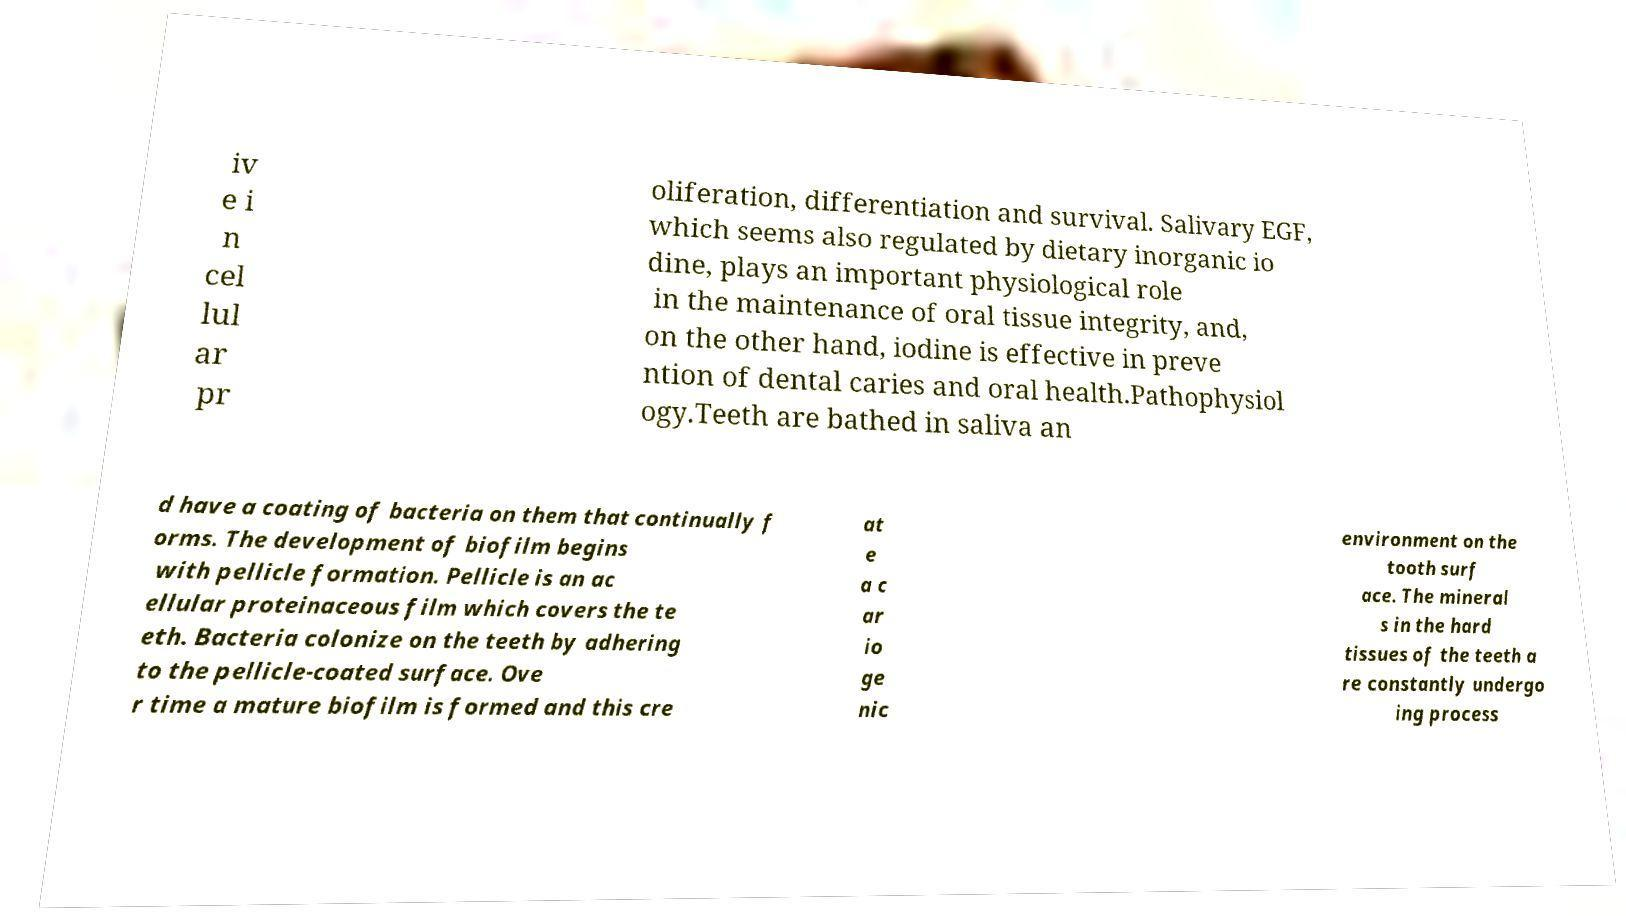Could you extract and type out the text from this image? iv e i n cel lul ar pr oliferation, differentiation and survival. Salivary EGF, which seems also regulated by dietary inorganic io dine, plays an important physiological role in the maintenance of oral tissue integrity, and, on the other hand, iodine is effective in preve ntion of dental caries and oral health.Pathophysiol ogy.Teeth are bathed in saliva an d have a coating of bacteria on them that continually f orms. The development of biofilm begins with pellicle formation. Pellicle is an ac ellular proteinaceous film which covers the te eth. Bacteria colonize on the teeth by adhering to the pellicle-coated surface. Ove r time a mature biofilm is formed and this cre at e a c ar io ge nic environment on the tooth surf ace. The mineral s in the hard tissues of the teeth a re constantly undergo ing process 